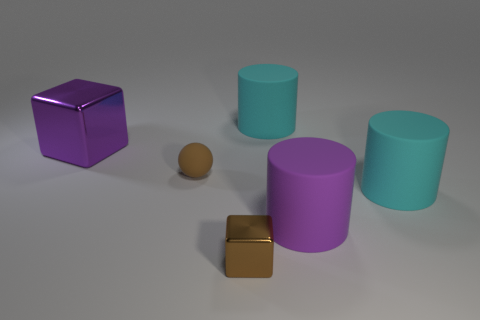What number of other objects are the same material as the big cube? In the image, there appears to be one small cube that shares the same shiny metallic material as the larger cube. Thus, there is one object of the same material. 